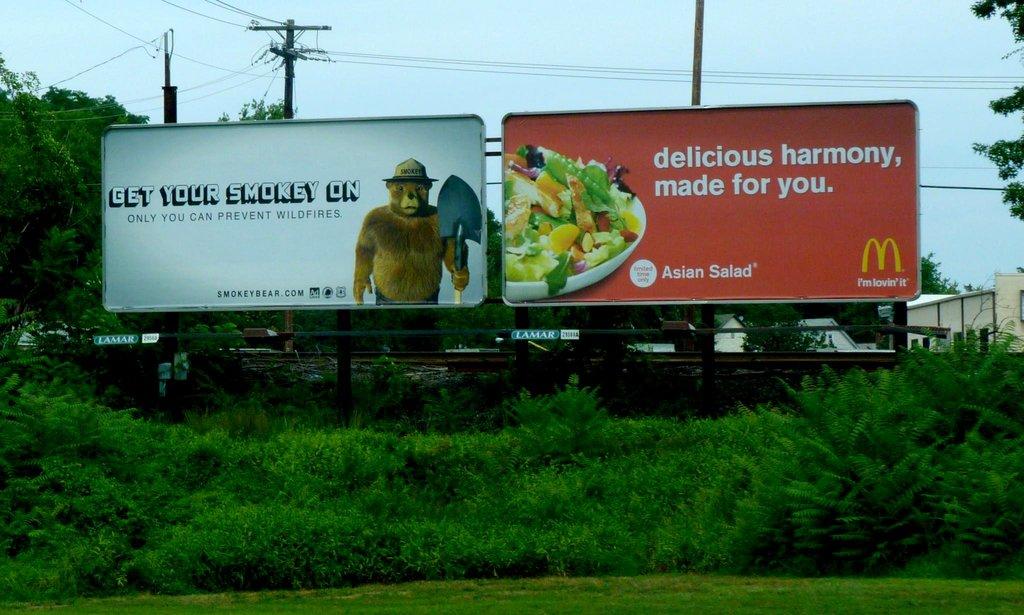What is the ad on the right?
Offer a terse response. Mcdonalds. 